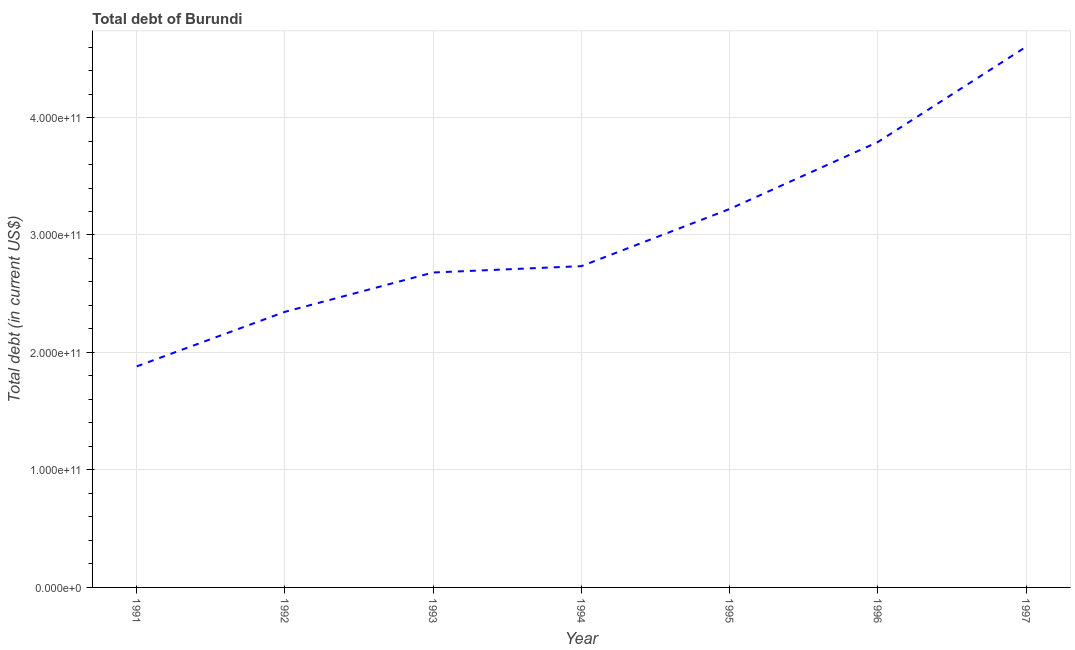What is the total debt in 1997?
Offer a terse response. 4.60e+11. Across all years, what is the maximum total debt?
Offer a very short reply. 4.60e+11. Across all years, what is the minimum total debt?
Make the answer very short. 1.88e+11. In which year was the total debt minimum?
Keep it short and to the point. 1991. What is the sum of the total debt?
Offer a terse response. 2.13e+12. What is the difference between the total debt in 1992 and 1996?
Your answer should be compact. -1.45e+11. What is the average total debt per year?
Give a very brief answer. 3.04e+11. What is the median total debt?
Your answer should be compact. 2.73e+11. In how many years, is the total debt greater than 100000000000 US$?
Your answer should be very brief. 7. Do a majority of the years between 1996 and 1991 (inclusive) have total debt greater than 80000000000 US$?
Offer a terse response. Yes. What is the ratio of the total debt in 1994 to that in 1997?
Your answer should be compact. 0.59. Is the total debt in 1993 less than that in 1996?
Provide a succinct answer. Yes. What is the difference between the highest and the second highest total debt?
Give a very brief answer. 8.11e+1. What is the difference between the highest and the lowest total debt?
Keep it short and to the point. 2.72e+11. In how many years, is the total debt greater than the average total debt taken over all years?
Your answer should be very brief. 3. Does the total debt monotonically increase over the years?
Provide a short and direct response. Yes. How many lines are there?
Provide a succinct answer. 1. How many years are there in the graph?
Ensure brevity in your answer.  7. What is the difference between two consecutive major ticks on the Y-axis?
Offer a very short reply. 1.00e+11. What is the title of the graph?
Your answer should be compact. Total debt of Burundi. What is the label or title of the Y-axis?
Your answer should be very brief. Total debt (in current US$). What is the Total debt (in current US$) in 1991?
Provide a short and direct response. 1.88e+11. What is the Total debt (in current US$) in 1992?
Make the answer very short. 2.35e+11. What is the Total debt (in current US$) in 1993?
Ensure brevity in your answer.  2.68e+11. What is the Total debt (in current US$) of 1994?
Give a very brief answer. 2.73e+11. What is the Total debt (in current US$) of 1995?
Give a very brief answer. 3.22e+11. What is the Total debt (in current US$) of 1996?
Keep it short and to the point. 3.79e+11. What is the Total debt (in current US$) of 1997?
Your response must be concise. 4.60e+11. What is the difference between the Total debt (in current US$) in 1991 and 1992?
Your response must be concise. -4.65e+1. What is the difference between the Total debt (in current US$) in 1991 and 1993?
Offer a very short reply. -7.99e+1. What is the difference between the Total debt (in current US$) in 1991 and 1994?
Provide a succinct answer. -8.53e+1. What is the difference between the Total debt (in current US$) in 1991 and 1995?
Keep it short and to the point. -1.34e+11. What is the difference between the Total debt (in current US$) in 1991 and 1996?
Your response must be concise. -1.91e+11. What is the difference between the Total debt (in current US$) in 1991 and 1997?
Give a very brief answer. -2.72e+11. What is the difference between the Total debt (in current US$) in 1992 and 1993?
Make the answer very short. -3.35e+1. What is the difference between the Total debt (in current US$) in 1992 and 1994?
Your answer should be compact. -3.89e+1. What is the difference between the Total debt (in current US$) in 1992 and 1995?
Your answer should be compact. -8.75e+1. What is the difference between the Total debt (in current US$) in 1992 and 1996?
Ensure brevity in your answer.  -1.45e+11. What is the difference between the Total debt (in current US$) in 1992 and 1997?
Ensure brevity in your answer.  -2.26e+11. What is the difference between the Total debt (in current US$) in 1993 and 1994?
Keep it short and to the point. -5.40e+09. What is the difference between the Total debt (in current US$) in 1993 and 1995?
Your response must be concise. -5.40e+1. What is the difference between the Total debt (in current US$) in 1993 and 1996?
Offer a very short reply. -1.11e+11. What is the difference between the Total debt (in current US$) in 1993 and 1997?
Your answer should be very brief. -1.92e+11. What is the difference between the Total debt (in current US$) in 1994 and 1995?
Ensure brevity in your answer.  -4.86e+1. What is the difference between the Total debt (in current US$) in 1994 and 1996?
Keep it short and to the point. -1.06e+11. What is the difference between the Total debt (in current US$) in 1994 and 1997?
Your answer should be compact. -1.87e+11. What is the difference between the Total debt (in current US$) in 1995 and 1996?
Ensure brevity in your answer.  -5.70e+1. What is the difference between the Total debt (in current US$) in 1995 and 1997?
Make the answer very short. -1.38e+11. What is the difference between the Total debt (in current US$) in 1996 and 1997?
Offer a terse response. -8.11e+1. What is the ratio of the Total debt (in current US$) in 1991 to that in 1992?
Give a very brief answer. 0.8. What is the ratio of the Total debt (in current US$) in 1991 to that in 1993?
Keep it short and to the point. 0.7. What is the ratio of the Total debt (in current US$) in 1991 to that in 1994?
Offer a terse response. 0.69. What is the ratio of the Total debt (in current US$) in 1991 to that in 1995?
Make the answer very short. 0.58. What is the ratio of the Total debt (in current US$) in 1991 to that in 1996?
Make the answer very short. 0.5. What is the ratio of the Total debt (in current US$) in 1991 to that in 1997?
Ensure brevity in your answer.  0.41. What is the ratio of the Total debt (in current US$) in 1992 to that in 1993?
Offer a terse response. 0.88. What is the ratio of the Total debt (in current US$) in 1992 to that in 1994?
Offer a very short reply. 0.86. What is the ratio of the Total debt (in current US$) in 1992 to that in 1995?
Keep it short and to the point. 0.73. What is the ratio of the Total debt (in current US$) in 1992 to that in 1996?
Make the answer very short. 0.62. What is the ratio of the Total debt (in current US$) in 1992 to that in 1997?
Offer a very short reply. 0.51. What is the ratio of the Total debt (in current US$) in 1993 to that in 1995?
Provide a succinct answer. 0.83. What is the ratio of the Total debt (in current US$) in 1993 to that in 1996?
Offer a terse response. 0.71. What is the ratio of the Total debt (in current US$) in 1993 to that in 1997?
Your answer should be compact. 0.58. What is the ratio of the Total debt (in current US$) in 1994 to that in 1995?
Provide a succinct answer. 0.85. What is the ratio of the Total debt (in current US$) in 1994 to that in 1996?
Ensure brevity in your answer.  0.72. What is the ratio of the Total debt (in current US$) in 1994 to that in 1997?
Offer a very short reply. 0.59. What is the ratio of the Total debt (in current US$) in 1995 to that in 1996?
Provide a short and direct response. 0.85. What is the ratio of the Total debt (in current US$) in 1995 to that in 1997?
Keep it short and to the point. 0.7. What is the ratio of the Total debt (in current US$) in 1996 to that in 1997?
Offer a very short reply. 0.82. 